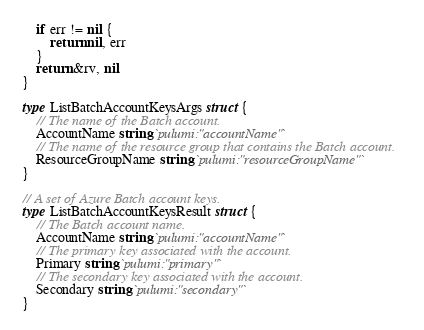<code> <loc_0><loc_0><loc_500><loc_500><_Go_>	if err != nil {
		return nil, err
	}
	return &rv, nil
}

type ListBatchAccountKeysArgs struct {
	// The name of the Batch account.
	AccountName string `pulumi:"accountName"`
	// The name of the resource group that contains the Batch account.
	ResourceGroupName string `pulumi:"resourceGroupName"`
}

// A set of Azure Batch account keys.
type ListBatchAccountKeysResult struct {
	// The Batch account name.
	AccountName string `pulumi:"accountName"`
	// The primary key associated with the account.
	Primary string `pulumi:"primary"`
	// The secondary key associated with the account.
	Secondary string `pulumi:"secondary"`
}
</code> 